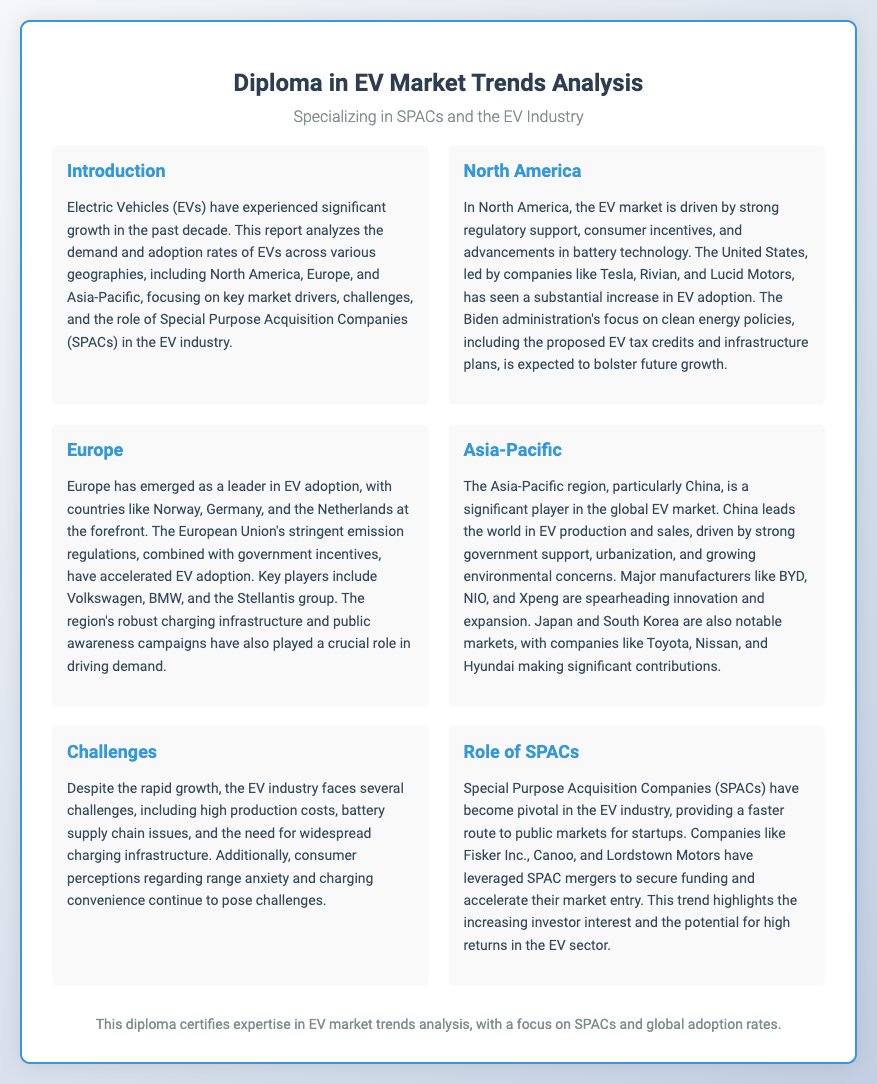What is the primary focus of the report? The primary focus of the report is on analyzing EV demand and adoption rates across various geographies and the role of SPACs in the EV industry.
Answer: EV demand and adoption rates Which region has emerged as a leader in EV adoption? The document mentions that Europe has emerged as a leader in EV adoption, particularly countries like Norway, Germany, and the Netherlands.
Answer: Europe Who are the major EV manufacturers in China? The report identifies BYD, NIO, and Xpeng as major manufacturers leading the innovation and expansion in the Chinese EV market.
Answer: BYD, NIO, Xpeng What are some challenges faced by the EV industry? The document outlines challenges such as high production costs, battery supply chain issues, and consumer perceptions related to range anxiety and charging convenience.
Answer: High production costs, battery supply chain issues What role do SPACs play in the EV industry? The role of SPACs is highlighted as providing a faster route to public markets for startups, helping secure funding and accelerate market entry.
Answer: Faster route to public markets How does consumer perception affect EV adoption? The document mentions that consumer perceptions regarding range anxiety and charging convenience continue to pose challenges for EV adoption.
Answer: Range anxiety and charging convenience Which administration's policies are expected to bolster future growth in the US EV market? The Biden administration's focus on clean energy policies, including proposed EV tax credits and infrastructure plans, is expected to bolster future growth.
Answer: Biden administration Which player is mentioned as leading the EV market in North America? The report notes that Tesla is a leading player in the North American EV market.
Answer: Tesla 